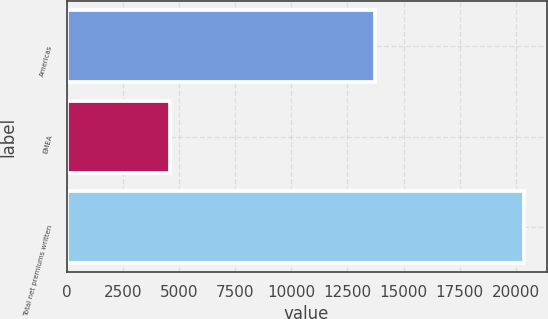Convert chart. <chart><loc_0><loc_0><loc_500><loc_500><bar_chart><fcel>Americas<fcel>EMEA<fcel>Total net premiums written<nl><fcel>13718<fcel>4614<fcel>20348<nl></chart> 